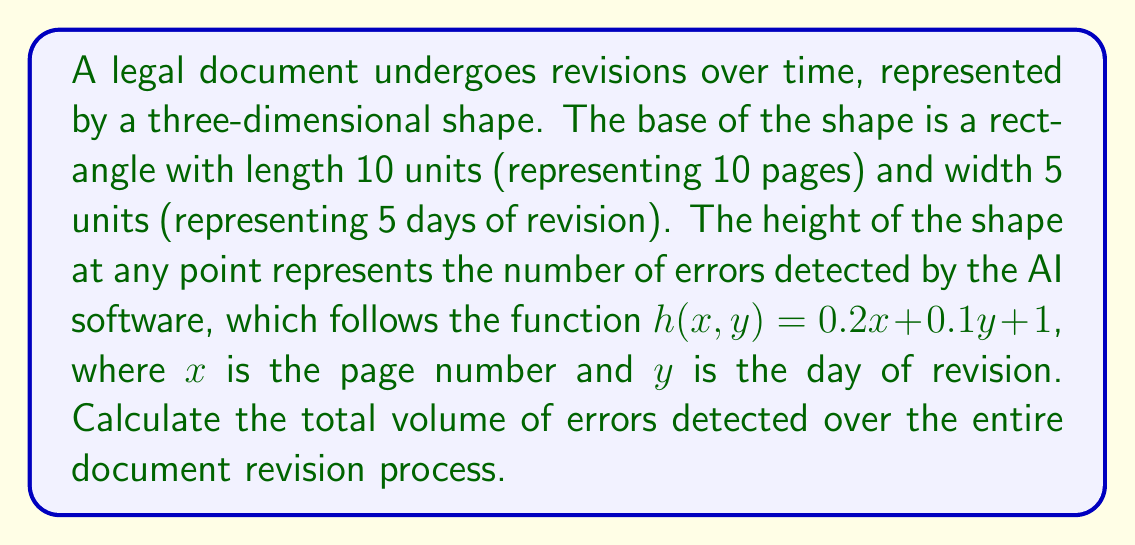Can you answer this question? To solve this problem, we need to use the concept of volume integrals. The steps are as follows:

1) The volume of a solid with a base area $A$ and height function $h(x,y)$ is given by the triple integral:

   $$V = \int\int_A h(x,y) dA$$

2) In this case, our base area $A$ is a rectangle with dimensions 10 by 5. The height function is given as $h(x,y) = 0.2x + 0.1y + 1$.

3) We can set up the triple integral as follows:

   $$V = \int_0^5 \int_0^{10} (0.2x + 0.1y + 1) dx dy$$

4) Let's solve the inner integral first:

   $$\int_0^{10} (0.2x + 0.1y + 1) dx = [0.1x^2 + 0.1yx + x]_0^{10}$$
   $$= (10 + y + 10) - (0) = 20 + y$$

5) Now our integral becomes:

   $$V = \int_0^5 (20 + y) dy$$

6) Solving this:

   $$V = [20y + \frac{1}{2}y^2]_0^5$$
   $$= (100 + 12.5) - (0) = 112.5$$

Therefore, the total volume of errors detected is 112.5 cubic units.
Answer: 112.5 cubic units 